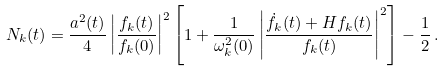<formula> <loc_0><loc_0><loc_500><loc_500>N _ { k } ( t ) = \frac { a ^ { 2 } ( t ) } { 4 } \left | \frac { f _ { k } ( t ) } { f _ { k } ( 0 ) } \right | ^ { 2 } \left [ 1 + \frac { 1 } { \omega ^ { 2 } _ { k } ( 0 ) } \left | \frac { \dot { f } _ { k } ( t ) + H f _ { k } ( t ) } { f _ { k } ( t ) } \right | ^ { 2 } \right ] - \frac { 1 } { 2 } \, .</formula> 